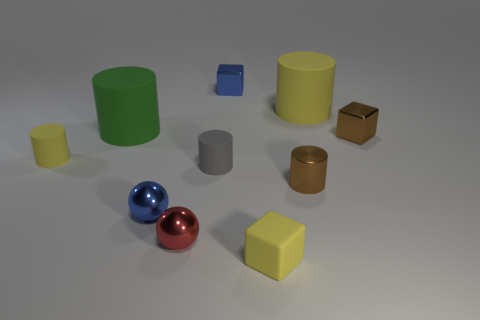Subtract all tiny blue cubes. How many cubes are left? 2 Subtract all blue balls. How many yellow cylinders are left? 2 Subtract all brown cubes. How many cubes are left? 2 Subtract 1 cubes. How many cubes are left? 2 Subtract all cyan cubes. Subtract all brown spheres. How many cubes are left? 3 Subtract all cubes. How many objects are left? 7 Subtract 1 green cylinders. How many objects are left? 9 Subtract all brown shiny blocks. Subtract all tiny red metallic things. How many objects are left? 8 Add 7 yellow blocks. How many yellow blocks are left? 8 Add 6 yellow rubber things. How many yellow rubber things exist? 9 